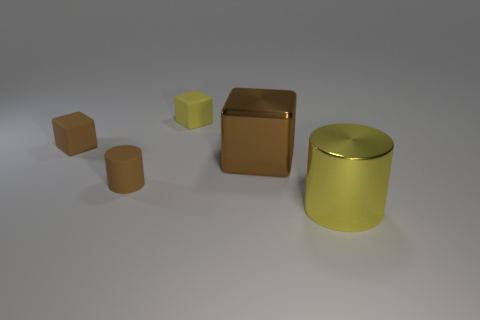What is the material of the tiny cube that is the same color as the big shiny cylinder?
Offer a terse response. Rubber. Is there a small cyan thing that has the same material as the yellow block?
Provide a succinct answer. No. Do the brown matte thing to the left of the brown matte cylinder and the big yellow cylinder have the same size?
Ensure brevity in your answer.  No. Are there any shiny objects behind the brown cube that is right of the tiny rubber object on the right side of the brown matte cylinder?
Make the answer very short. No. What number of matte objects are tiny objects or small yellow blocks?
Provide a succinct answer. 3. How many other objects are the same shape as the small yellow thing?
Provide a succinct answer. 2. Is the number of balls greater than the number of metal objects?
Your answer should be compact. No. There is a brown cube on the left side of the large metallic thing that is behind the cylinder in front of the small brown cylinder; how big is it?
Provide a succinct answer. Small. There is a brown cube that is to the left of the large cube; what is its size?
Your answer should be compact. Small. How many things are either large red matte blocks or small matte objects that are behind the big brown metallic object?
Give a very brief answer. 2. 